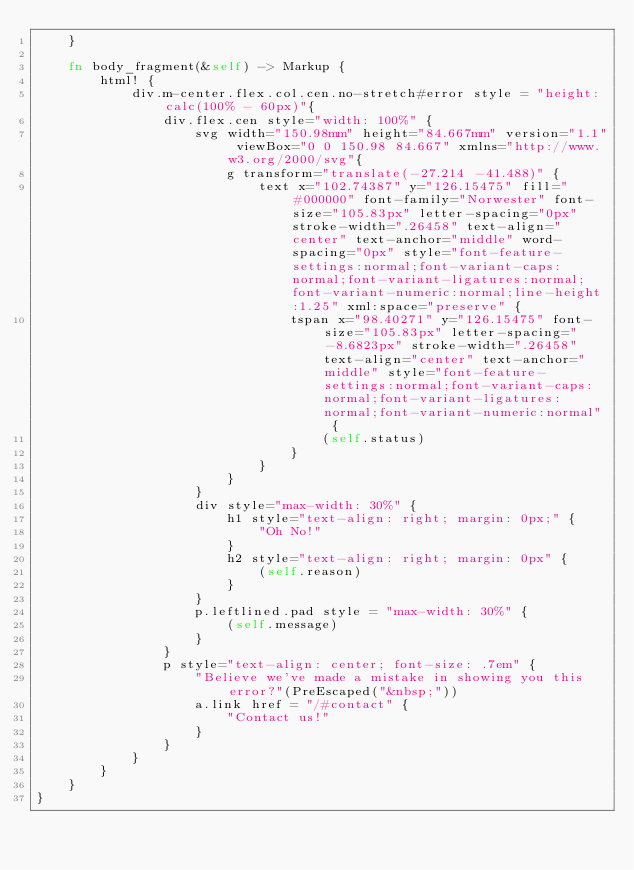<code> <loc_0><loc_0><loc_500><loc_500><_Rust_>    }

    fn body_fragment(&self) -> Markup {
        html! {
            div.m-center.flex.col.cen.no-stretch#error style = "height: calc(100% - 60px)"{
                div.flex.cen style="width: 100%" {
                    svg width="150.98mm" height="84.667mm" version="1.1" viewBox="0 0 150.98 84.667" xmlns="http://www.w3.org/2000/svg"{
                        g transform="translate(-27.214 -41.488)" {
                            text x="102.74387" y="126.15475" fill="#000000" font-family="Norwester" font-size="105.83px" letter-spacing="0px" stroke-width=".26458" text-align="center" text-anchor="middle" word-spacing="0px" style="font-feature-settings:normal;font-variant-caps:normal;font-variant-ligatures:normal;font-variant-numeric:normal;line-height:1.25" xml:space="preserve" {
                                tspan x="98.40271" y="126.15475" font-size="105.83px" letter-spacing="-8.6823px" stroke-width=".26458" text-align="center" text-anchor="middle" style="font-feature-settings:normal;font-variant-caps:normal;font-variant-ligatures:normal;font-variant-numeric:normal" {
                                    (self.status)
                                }
                            }
                        }
                    }
                    div style="max-width: 30%" {
                        h1 style="text-align: right; margin: 0px;" {
                            "Oh No!"
                        }
                        h2 style="text-align: right; margin: 0px" {
                            (self.reason)
                        }
                    }
                    p.leftlined.pad style = "max-width: 30%" {
                        (self.message)
                    }
                }
                p style="text-align: center; font-size: .7em" {
                    "Believe we've made a mistake in showing you this error?"(PreEscaped("&nbsp;"))
                    a.link href = "/#contact" {
                        "Contact us!"
                    }
                }
            }
        }
    }
}
</code> 